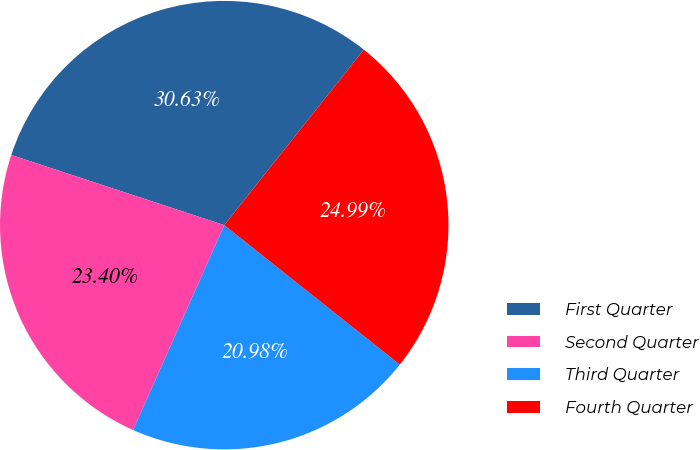Convert chart. <chart><loc_0><loc_0><loc_500><loc_500><pie_chart><fcel>First Quarter<fcel>Second Quarter<fcel>Third Quarter<fcel>Fourth Quarter<nl><fcel>30.63%<fcel>23.4%<fcel>20.98%<fcel>24.99%<nl></chart> 